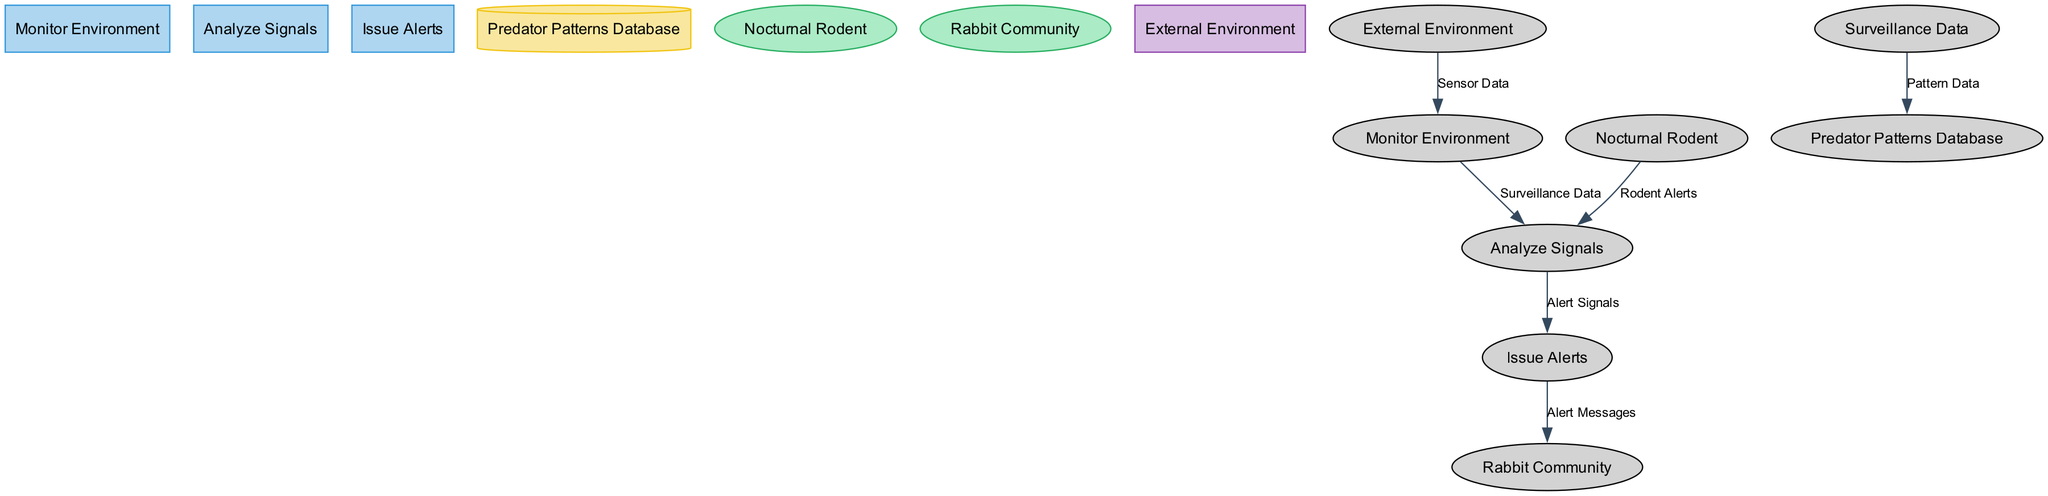How many processes are in the diagram? The diagram lists three processes: Monitor Environment, Analyze Signals, and Issue Alerts.
Answer: 3 What is the output of the Analyze Signals process? The Analyze Signals process produces "Alert Signals" as its output.
Answer: Alert Signals What type of node is the Predator Patterns Database? Upon examining the nodes, the Predator Patterns Database is classified as a data store, which typically appears in a cylinder shape.
Answer: Data Store Which external entity outputs Alert Messages? The Rabbit Community is the external entity that receives and processes the Alert Messages from the Issue Alerts process.
Answer: Rabbit Community What input does the Monitor Environment process require? The Monitor Environment process needs "Sensor Data" as an input to function.
Answer: Sensor Data How many data flows connect the Nocturnal Rodent to the diagram? There is one data flow that connects the Nocturnal Rodent to the Analyze Signals process, identified as Rodent Alerts.
Answer: 1 What do the Alert Messages trigger in the Rabbit Community? The Alert Messages from the Issue Alerts process prompt the Rabbit Community to have "Safety Responses."
Answer: Safety Responses What is the purpose of the Predator Patterns Database? The Predator Patterns Database serves to store historical patterns and behaviors of nocturnal predators for future reference and analysis.
Answer: Store Historical Patterns Which process has the most immediate output after gathering data? The Analyze Signals process immediately outputs Alert Signals after processing the Surveillance Data received from the Monitor Environment process.
Answer: Analyze Signals 